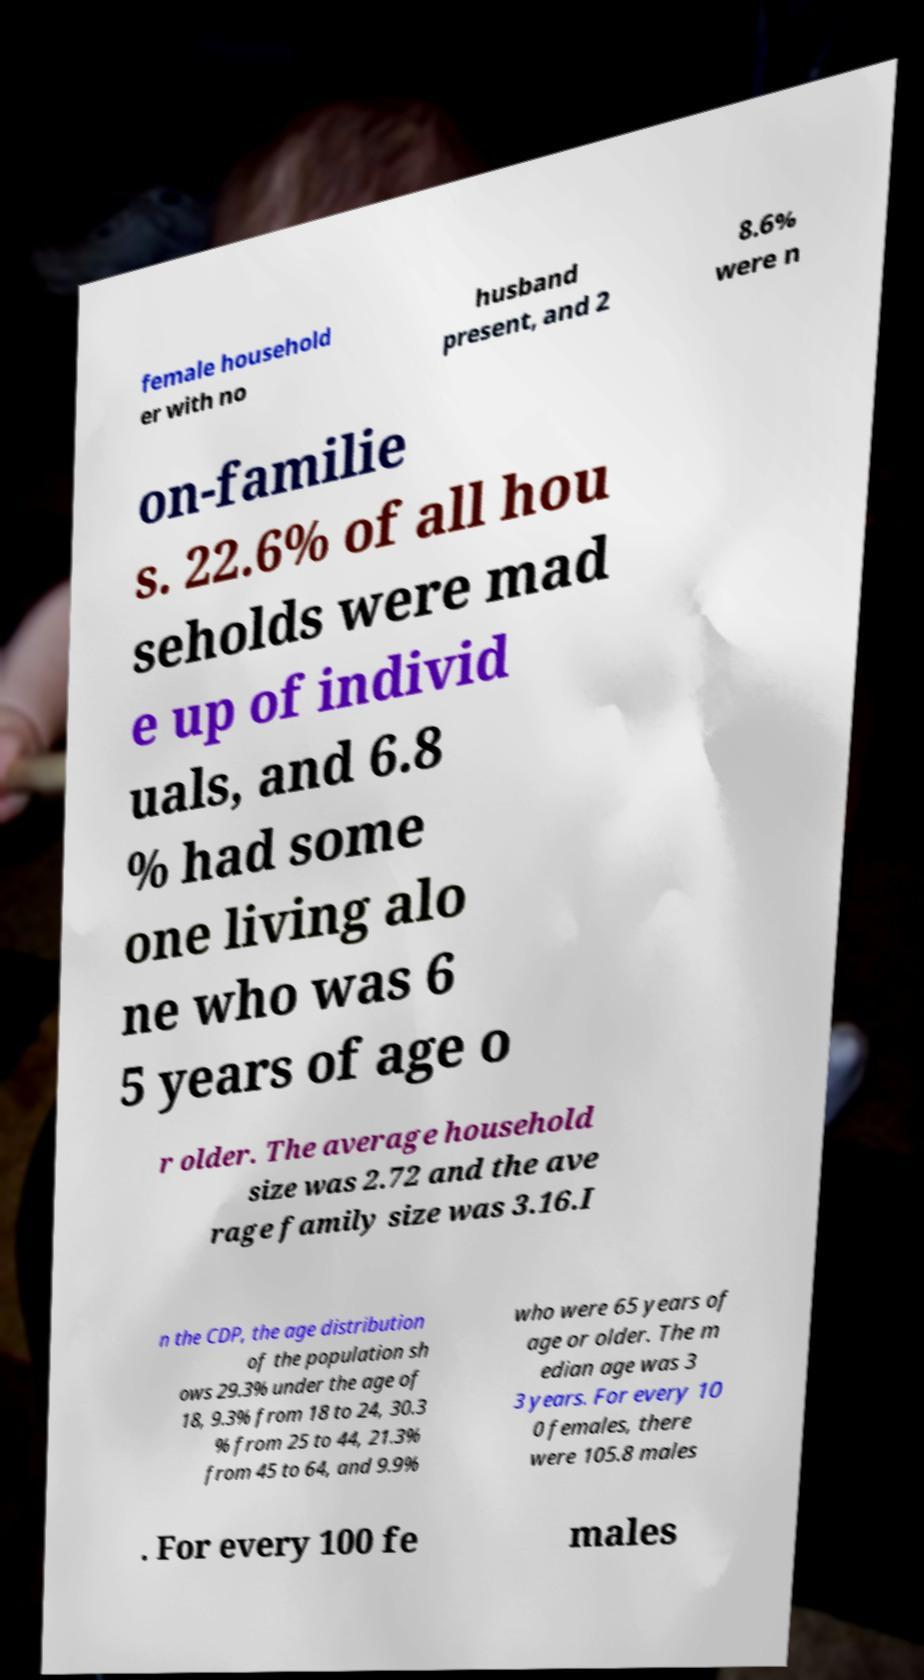For documentation purposes, I need the text within this image transcribed. Could you provide that? female household er with no husband present, and 2 8.6% were n on-familie s. 22.6% of all hou seholds were mad e up of individ uals, and 6.8 % had some one living alo ne who was 6 5 years of age o r older. The average household size was 2.72 and the ave rage family size was 3.16.I n the CDP, the age distribution of the population sh ows 29.3% under the age of 18, 9.3% from 18 to 24, 30.3 % from 25 to 44, 21.3% from 45 to 64, and 9.9% who were 65 years of age or older. The m edian age was 3 3 years. For every 10 0 females, there were 105.8 males . For every 100 fe males 